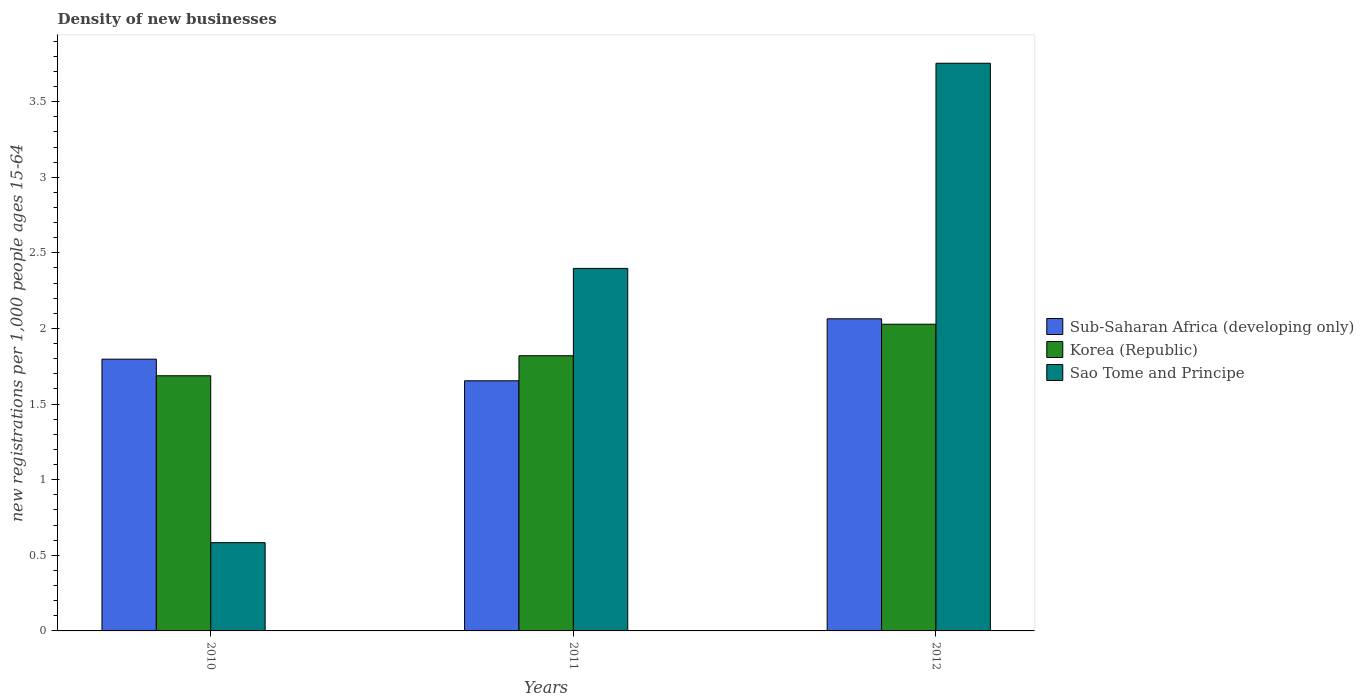How many different coloured bars are there?
Offer a terse response. 3. What is the label of the 3rd group of bars from the left?
Your answer should be compact. 2012. In how many cases, is the number of bars for a given year not equal to the number of legend labels?
Make the answer very short. 0. What is the number of new registrations in Sao Tome and Principe in 2010?
Provide a short and direct response. 0.58. Across all years, what is the maximum number of new registrations in Korea (Republic)?
Give a very brief answer. 2.03. Across all years, what is the minimum number of new registrations in Korea (Republic)?
Make the answer very short. 1.69. What is the total number of new registrations in Sao Tome and Principe in the graph?
Your answer should be very brief. 6.73. What is the difference between the number of new registrations in Korea (Republic) in 2010 and that in 2011?
Give a very brief answer. -0.13. What is the difference between the number of new registrations in Sub-Saharan Africa (developing only) in 2011 and the number of new registrations in Sao Tome and Principe in 2010?
Give a very brief answer. 1.07. What is the average number of new registrations in Sao Tome and Principe per year?
Provide a short and direct response. 2.24. In the year 2010, what is the difference between the number of new registrations in Sub-Saharan Africa (developing only) and number of new registrations in Korea (Republic)?
Your answer should be compact. 0.11. In how many years, is the number of new registrations in Korea (Republic) greater than 0.5?
Your response must be concise. 3. What is the ratio of the number of new registrations in Sao Tome and Principe in 2011 to that in 2012?
Your answer should be compact. 0.64. Is the number of new registrations in Korea (Republic) in 2010 less than that in 2011?
Provide a short and direct response. Yes. What is the difference between the highest and the second highest number of new registrations in Sub-Saharan Africa (developing only)?
Your answer should be compact. 0.27. What is the difference between the highest and the lowest number of new registrations in Korea (Republic)?
Provide a short and direct response. 0.34. Is the sum of the number of new registrations in Korea (Republic) in 2011 and 2012 greater than the maximum number of new registrations in Sao Tome and Principe across all years?
Your answer should be very brief. Yes. What does the 1st bar from the left in 2012 represents?
Your response must be concise. Sub-Saharan Africa (developing only). What does the 2nd bar from the right in 2012 represents?
Provide a short and direct response. Korea (Republic). Is it the case that in every year, the sum of the number of new registrations in Korea (Republic) and number of new registrations in Sub-Saharan Africa (developing only) is greater than the number of new registrations in Sao Tome and Principe?
Ensure brevity in your answer.  Yes. How many bars are there?
Offer a terse response. 9. Are all the bars in the graph horizontal?
Offer a terse response. No. How many years are there in the graph?
Your answer should be very brief. 3. What is the difference between two consecutive major ticks on the Y-axis?
Your answer should be compact. 0.5. Are the values on the major ticks of Y-axis written in scientific E-notation?
Offer a very short reply. No. Where does the legend appear in the graph?
Your answer should be compact. Center right. How many legend labels are there?
Keep it short and to the point. 3. How are the legend labels stacked?
Ensure brevity in your answer.  Vertical. What is the title of the graph?
Provide a succinct answer. Density of new businesses. Does "Belarus" appear as one of the legend labels in the graph?
Provide a short and direct response. No. What is the label or title of the X-axis?
Keep it short and to the point. Years. What is the label or title of the Y-axis?
Provide a short and direct response. New registrations per 1,0 people ages 15-64. What is the new registrations per 1,000 people ages 15-64 of Sub-Saharan Africa (developing only) in 2010?
Your response must be concise. 1.8. What is the new registrations per 1,000 people ages 15-64 in Korea (Republic) in 2010?
Make the answer very short. 1.69. What is the new registrations per 1,000 people ages 15-64 in Sao Tome and Principe in 2010?
Offer a terse response. 0.58. What is the new registrations per 1,000 people ages 15-64 in Sub-Saharan Africa (developing only) in 2011?
Make the answer very short. 1.65. What is the new registrations per 1,000 people ages 15-64 of Korea (Republic) in 2011?
Provide a short and direct response. 1.82. What is the new registrations per 1,000 people ages 15-64 of Sao Tome and Principe in 2011?
Your response must be concise. 2.4. What is the new registrations per 1,000 people ages 15-64 of Sub-Saharan Africa (developing only) in 2012?
Give a very brief answer. 2.06. What is the new registrations per 1,000 people ages 15-64 in Korea (Republic) in 2012?
Provide a succinct answer. 2.03. What is the new registrations per 1,000 people ages 15-64 of Sao Tome and Principe in 2012?
Offer a terse response. 3.75. Across all years, what is the maximum new registrations per 1,000 people ages 15-64 in Sub-Saharan Africa (developing only)?
Provide a succinct answer. 2.06. Across all years, what is the maximum new registrations per 1,000 people ages 15-64 of Korea (Republic)?
Your answer should be very brief. 2.03. Across all years, what is the maximum new registrations per 1,000 people ages 15-64 of Sao Tome and Principe?
Provide a short and direct response. 3.75. Across all years, what is the minimum new registrations per 1,000 people ages 15-64 of Sub-Saharan Africa (developing only)?
Your response must be concise. 1.65. Across all years, what is the minimum new registrations per 1,000 people ages 15-64 in Korea (Republic)?
Make the answer very short. 1.69. Across all years, what is the minimum new registrations per 1,000 people ages 15-64 in Sao Tome and Principe?
Keep it short and to the point. 0.58. What is the total new registrations per 1,000 people ages 15-64 in Sub-Saharan Africa (developing only) in the graph?
Your answer should be compact. 5.52. What is the total new registrations per 1,000 people ages 15-64 of Korea (Republic) in the graph?
Offer a very short reply. 5.54. What is the total new registrations per 1,000 people ages 15-64 of Sao Tome and Principe in the graph?
Give a very brief answer. 6.73. What is the difference between the new registrations per 1,000 people ages 15-64 in Sub-Saharan Africa (developing only) in 2010 and that in 2011?
Ensure brevity in your answer.  0.14. What is the difference between the new registrations per 1,000 people ages 15-64 in Korea (Republic) in 2010 and that in 2011?
Offer a terse response. -0.13. What is the difference between the new registrations per 1,000 people ages 15-64 in Sao Tome and Principe in 2010 and that in 2011?
Your answer should be very brief. -1.81. What is the difference between the new registrations per 1,000 people ages 15-64 in Sub-Saharan Africa (developing only) in 2010 and that in 2012?
Your answer should be compact. -0.27. What is the difference between the new registrations per 1,000 people ages 15-64 in Korea (Republic) in 2010 and that in 2012?
Give a very brief answer. -0.34. What is the difference between the new registrations per 1,000 people ages 15-64 of Sao Tome and Principe in 2010 and that in 2012?
Give a very brief answer. -3.17. What is the difference between the new registrations per 1,000 people ages 15-64 of Sub-Saharan Africa (developing only) in 2011 and that in 2012?
Your answer should be compact. -0.41. What is the difference between the new registrations per 1,000 people ages 15-64 of Korea (Republic) in 2011 and that in 2012?
Offer a terse response. -0.21. What is the difference between the new registrations per 1,000 people ages 15-64 of Sao Tome and Principe in 2011 and that in 2012?
Your response must be concise. -1.36. What is the difference between the new registrations per 1,000 people ages 15-64 in Sub-Saharan Africa (developing only) in 2010 and the new registrations per 1,000 people ages 15-64 in Korea (Republic) in 2011?
Give a very brief answer. -0.02. What is the difference between the new registrations per 1,000 people ages 15-64 in Sub-Saharan Africa (developing only) in 2010 and the new registrations per 1,000 people ages 15-64 in Sao Tome and Principe in 2011?
Your answer should be very brief. -0.6. What is the difference between the new registrations per 1,000 people ages 15-64 of Korea (Republic) in 2010 and the new registrations per 1,000 people ages 15-64 of Sao Tome and Principe in 2011?
Your answer should be compact. -0.71. What is the difference between the new registrations per 1,000 people ages 15-64 of Sub-Saharan Africa (developing only) in 2010 and the new registrations per 1,000 people ages 15-64 of Korea (Republic) in 2012?
Your response must be concise. -0.23. What is the difference between the new registrations per 1,000 people ages 15-64 in Sub-Saharan Africa (developing only) in 2010 and the new registrations per 1,000 people ages 15-64 in Sao Tome and Principe in 2012?
Provide a short and direct response. -1.96. What is the difference between the new registrations per 1,000 people ages 15-64 of Korea (Republic) in 2010 and the new registrations per 1,000 people ages 15-64 of Sao Tome and Principe in 2012?
Your answer should be very brief. -2.07. What is the difference between the new registrations per 1,000 people ages 15-64 in Sub-Saharan Africa (developing only) in 2011 and the new registrations per 1,000 people ages 15-64 in Korea (Republic) in 2012?
Give a very brief answer. -0.37. What is the difference between the new registrations per 1,000 people ages 15-64 of Sub-Saharan Africa (developing only) in 2011 and the new registrations per 1,000 people ages 15-64 of Sao Tome and Principe in 2012?
Ensure brevity in your answer.  -2.1. What is the difference between the new registrations per 1,000 people ages 15-64 of Korea (Republic) in 2011 and the new registrations per 1,000 people ages 15-64 of Sao Tome and Principe in 2012?
Offer a terse response. -1.93. What is the average new registrations per 1,000 people ages 15-64 of Sub-Saharan Africa (developing only) per year?
Keep it short and to the point. 1.84. What is the average new registrations per 1,000 people ages 15-64 in Korea (Republic) per year?
Offer a terse response. 1.85. What is the average new registrations per 1,000 people ages 15-64 of Sao Tome and Principe per year?
Your answer should be compact. 2.24. In the year 2010, what is the difference between the new registrations per 1,000 people ages 15-64 of Sub-Saharan Africa (developing only) and new registrations per 1,000 people ages 15-64 of Korea (Republic)?
Your response must be concise. 0.11. In the year 2010, what is the difference between the new registrations per 1,000 people ages 15-64 of Sub-Saharan Africa (developing only) and new registrations per 1,000 people ages 15-64 of Sao Tome and Principe?
Your response must be concise. 1.21. In the year 2010, what is the difference between the new registrations per 1,000 people ages 15-64 of Korea (Republic) and new registrations per 1,000 people ages 15-64 of Sao Tome and Principe?
Your answer should be very brief. 1.1. In the year 2011, what is the difference between the new registrations per 1,000 people ages 15-64 in Sub-Saharan Africa (developing only) and new registrations per 1,000 people ages 15-64 in Korea (Republic)?
Ensure brevity in your answer.  -0.17. In the year 2011, what is the difference between the new registrations per 1,000 people ages 15-64 in Sub-Saharan Africa (developing only) and new registrations per 1,000 people ages 15-64 in Sao Tome and Principe?
Keep it short and to the point. -0.74. In the year 2011, what is the difference between the new registrations per 1,000 people ages 15-64 in Korea (Republic) and new registrations per 1,000 people ages 15-64 in Sao Tome and Principe?
Make the answer very short. -0.58. In the year 2012, what is the difference between the new registrations per 1,000 people ages 15-64 in Sub-Saharan Africa (developing only) and new registrations per 1,000 people ages 15-64 in Korea (Republic)?
Ensure brevity in your answer.  0.04. In the year 2012, what is the difference between the new registrations per 1,000 people ages 15-64 of Sub-Saharan Africa (developing only) and new registrations per 1,000 people ages 15-64 of Sao Tome and Principe?
Make the answer very short. -1.69. In the year 2012, what is the difference between the new registrations per 1,000 people ages 15-64 of Korea (Republic) and new registrations per 1,000 people ages 15-64 of Sao Tome and Principe?
Ensure brevity in your answer.  -1.73. What is the ratio of the new registrations per 1,000 people ages 15-64 of Sub-Saharan Africa (developing only) in 2010 to that in 2011?
Give a very brief answer. 1.09. What is the ratio of the new registrations per 1,000 people ages 15-64 in Korea (Republic) in 2010 to that in 2011?
Your answer should be very brief. 0.93. What is the ratio of the new registrations per 1,000 people ages 15-64 of Sao Tome and Principe in 2010 to that in 2011?
Your response must be concise. 0.24. What is the ratio of the new registrations per 1,000 people ages 15-64 of Sub-Saharan Africa (developing only) in 2010 to that in 2012?
Your answer should be very brief. 0.87. What is the ratio of the new registrations per 1,000 people ages 15-64 of Korea (Republic) in 2010 to that in 2012?
Provide a short and direct response. 0.83. What is the ratio of the new registrations per 1,000 people ages 15-64 of Sao Tome and Principe in 2010 to that in 2012?
Your answer should be very brief. 0.16. What is the ratio of the new registrations per 1,000 people ages 15-64 of Sub-Saharan Africa (developing only) in 2011 to that in 2012?
Provide a short and direct response. 0.8. What is the ratio of the new registrations per 1,000 people ages 15-64 in Korea (Republic) in 2011 to that in 2012?
Your answer should be compact. 0.9. What is the ratio of the new registrations per 1,000 people ages 15-64 of Sao Tome and Principe in 2011 to that in 2012?
Your answer should be compact. 0.64. What is the difference between the highest and the second highest new registrations per 1,000 people ages 15-64 of Sub-Saharan Africa (developing only)?
Make the answer very short. 0.27. What is the difference between the highest and the second highest new registrations per 1,000 people ages 15-64 of Korea (Republic)?
Make the answer very short. 0.21. What is the difference between the highest and the second highest new registrations per 1,000 people ages 15-64 in Sao Tome and Principe?
Provide a short and direct response. 1.36. What is the difference between the highest and the lowest new registrations per 1,000 people ages 15-64 of Sub-Saharan Africa (developing only)?
Your answer should be compact. 0.41. What is the difference between the highest and the lowest new registrations per 1,000 people ages 15-64 in Korea (Republic)?
Provide a succinct answer. 0.34. What is the difference between the highest and the lowest new registrations per 1,000 people ages 15-64 in Sao Tome and Principe?
Offer a very short reply. 3.17. 